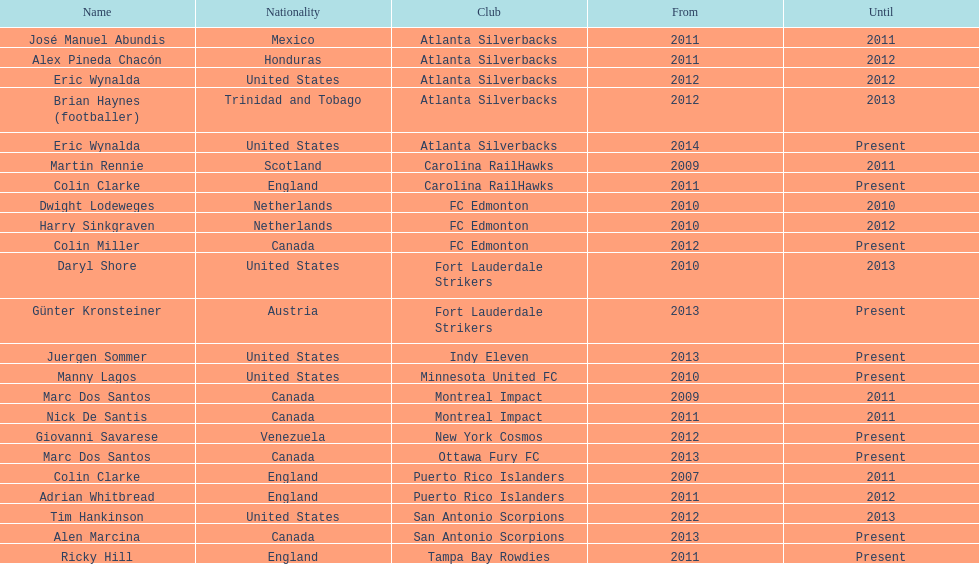How many years did colin clarke serve as the coach for the puerto rico islanders? 4 years. 